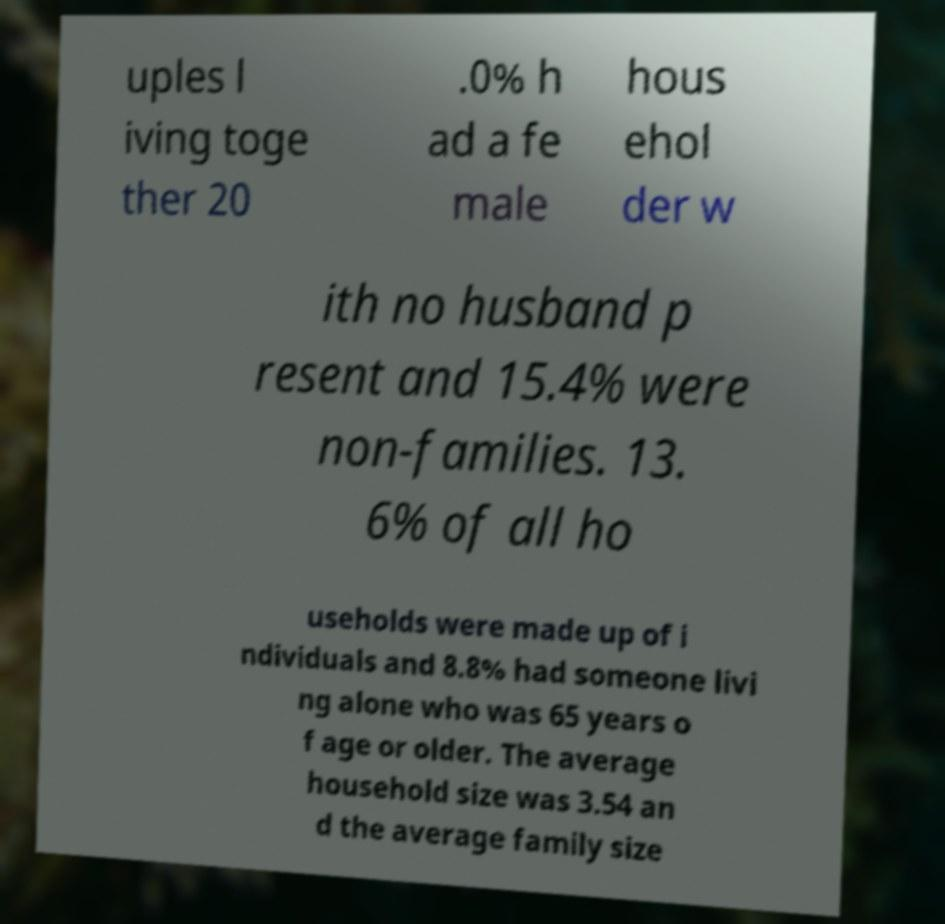What messages or text are displayed in this image? I need them in a readable, typed format. uples l iving toge ther 20 .0% h ad a fe male hous ehol der w ith no husband p resent and 15.4% were non-families. 13. 6% of all ho useholds were made up of i ndividuals and 8.8% had someone livi ng alone who was 65 years o f age or older. The average household size was 3.54 an d the average family size 